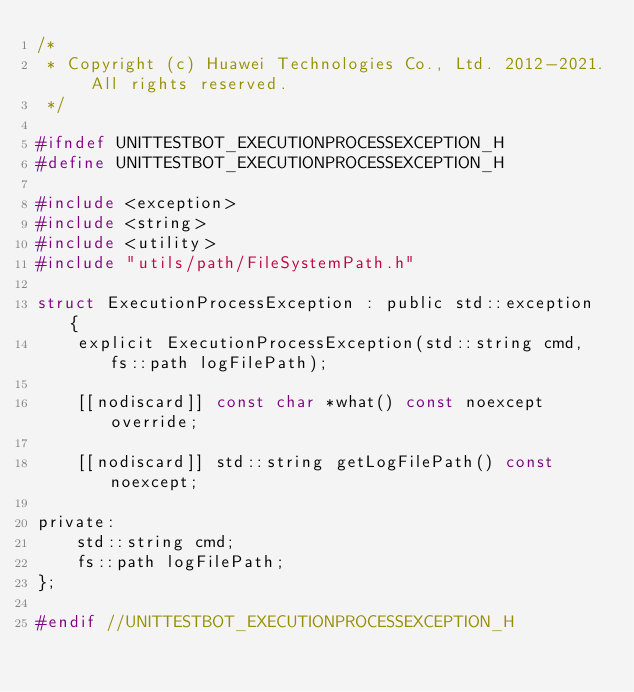Convert code to text. <code><loc_0><loc_0><loc_500><loc_500><_C_>/*
 * Copyright (c) Huawei Technologies Co., Ltd. 2012-2021. All rights reserved.
 */

#ifndef UNITTESTBOT_EXECUTIONPROCESSEXCEPTION_H
#define UNITTESTBOT_EXECUTIONPROCESSEXCEPTION_H

#include <exception>
#include <string>
#include <utility>
#include "utils/path/FileSystemPath.h"

struct ExecutionProcessException : public std::exception {
    explicit ExecutionProcessException(std::string cmd, fs::path logFilePath);

    [[nodiscard]] const char *what() const noexcept override;

    [[nodiscard]] std::string getLogFilePath() const noexcept;

private:
    std::string cmd;
    fs::path logFilePath;
};

#endif //UNITTESTBOT_EXECUTIONPROCESSEXCEPTION_H
</code> 